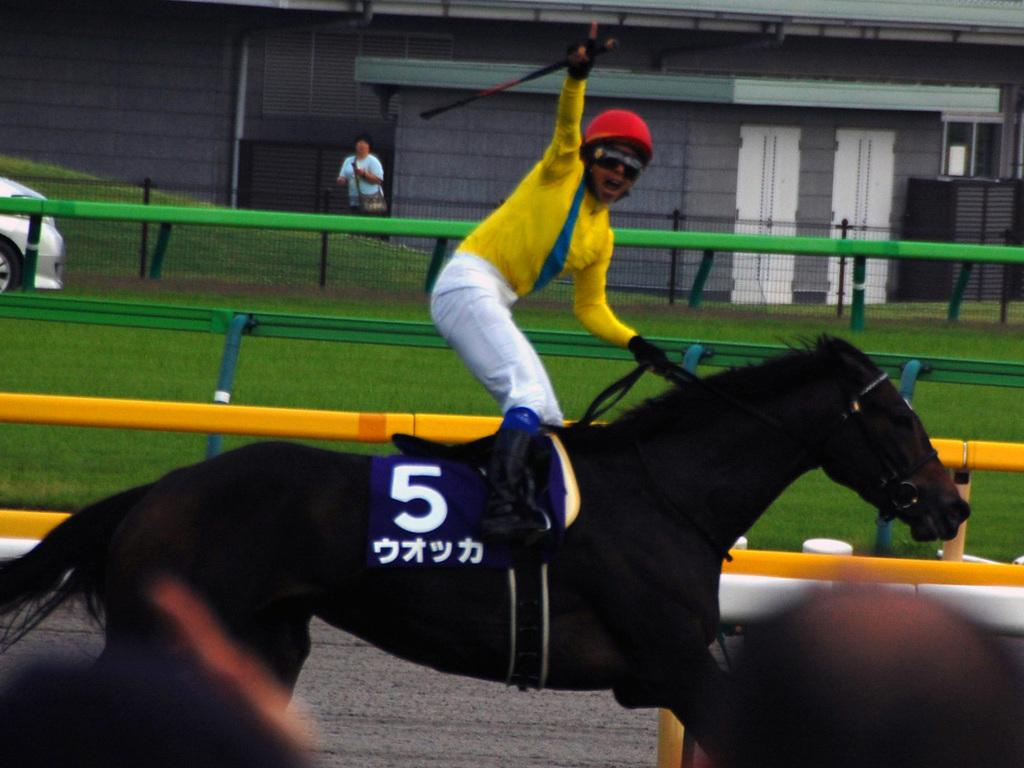What is the main subject of the image? There is a person on a horse in the image. What can be seen in the background of the image? There is a fence, grass, a vehicle, a person, and a building in the background of the image. Can you describe the setting of the image? The image appears to be set in an outdoor area with a fence, grass, and a building visible in the background. How does the horse's digestion process work in the image? There is no information about the horse's digestion process in the image. What level of experience does the person on the horse have, according to the image? The image does not provide any information about the person's experience level on the horse. 